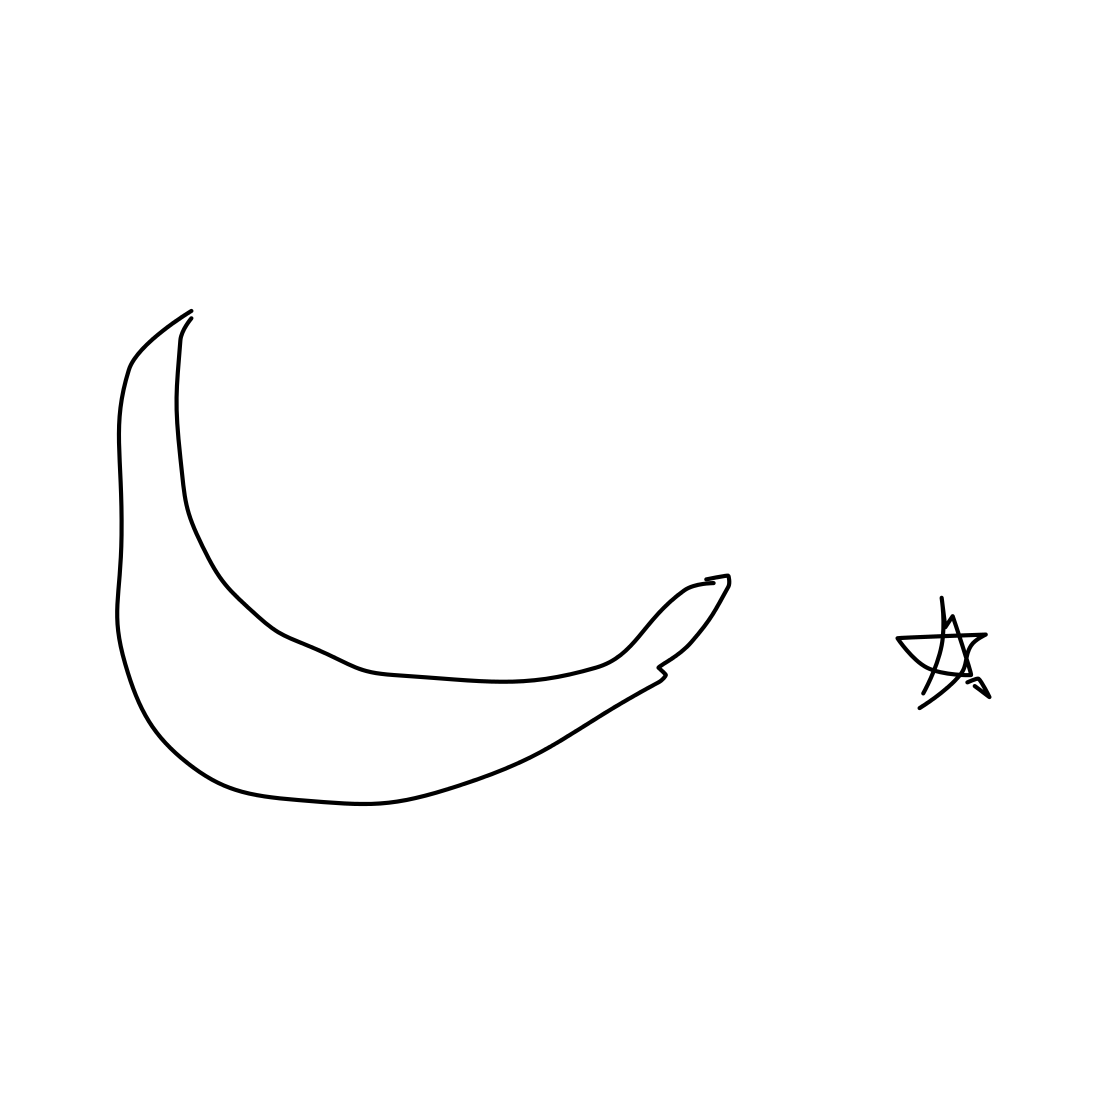How do the simple lines used to draw the banana affect its representation? The minimalist use of simple lines to portray the banana focuses attention on its basic, recognizable shape, emphasizing clarity and immediate recognition. This stylistic choice strips away unnecessary details and could suggest a modern or abstract artistic approach, allowing the viewer to fill in the blanks or focus on the form and symbolism rather than realistic details. 